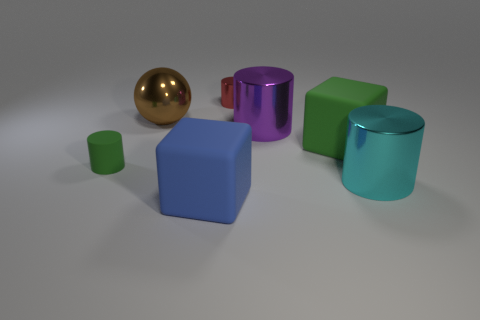Are there any large rubber blocks that have the same color as the small rubber thing?
Provide a succinct answer. Yes. There is another metal cylinder that is the same size as the purple metallic cylinder; what color is it?
Ensure brevity in your answer.  Cyan. There is a small cylinder that is behind the big green block; what number of small green matte cylinders are to the left of it?
Provide a short and direct response. 1. What number of rubber things are behind the cyan metal cylinder and to the left of the red shiny cylinder?
Make the answer very short. 1. How many objects are green rubber things that are left of the big green rubber cube or big things that are in front of the large purple thing?
Your response must be concise. 4. How many other objects are the same size as the red cylinder?
Give a very brief answer. 1. There is a small object on the left side of the big rubber cube that is on the left side of the red thing; what is its shape?
Offer a terse response. Cylinder. There is a cylinder that is on the left side of the shiny sphere; is its color the same as the matte block that is behind the cyan cylinder?
Your response must be concise. Yes. Is there anything else of the same color as the matte cylinder?
Offer a terse response. Yes. The tiny metal thing is what color?
Your response must be concise. Red. 